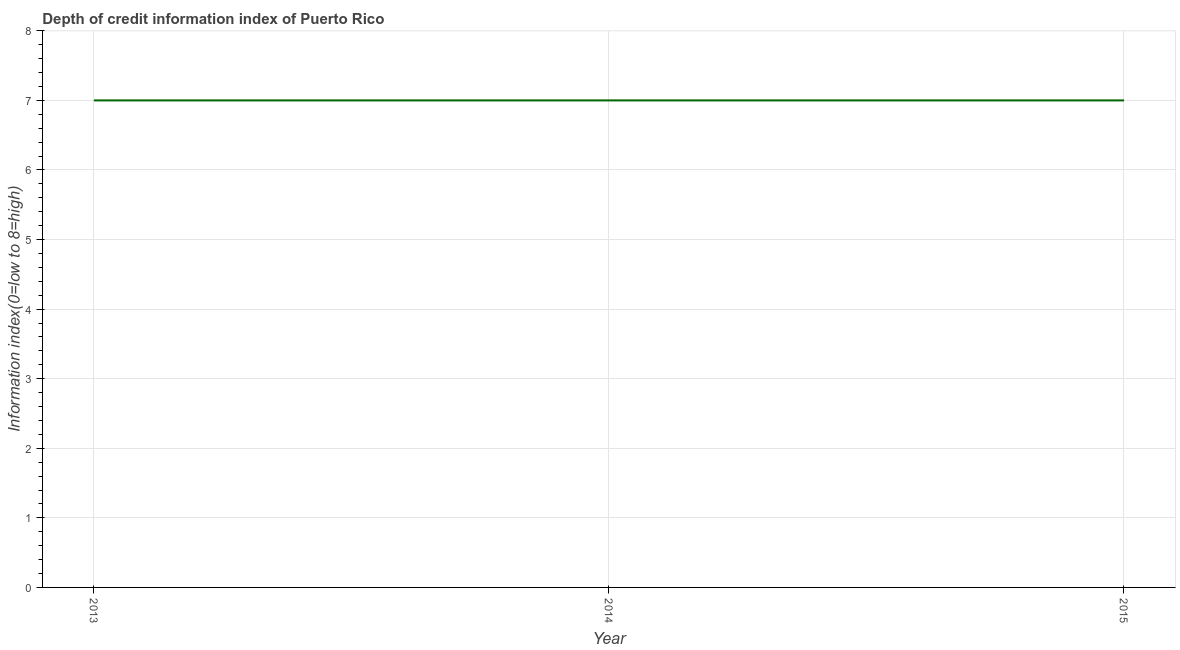What is the depth of credit information index in 2014?
Your answer should be very brief. 7. Across all years, what is the maximum depth of credit information index?
Provide a short and direct response. 7. Across all years, what is the minimum depth of credit information index?
Your response must be concise. 7. In which year was the depth of credit information index maximum?
Provide a succinct answer. 2013. In which year was the depth of credit information index minimum?
Your answer should be very brief. 2013. What is the sum of the depth of credit information index?
Your answer should be very brief. 21. What is the difference between the depth of credit information index in 2014 and 2015?
Provide a succinct answer. 0. What is the average depth of credit information index per year?
Ensure brevity in your answer.  7. In how many years, is the depth of credit information index greater than 3.4 ?
Offer a very short reply. 3. Do a majority of the years between 2015 and 2014 (inclusive) have depth of credit information index greater than 4.2 ?
Ensure brevity in your answer.  No. Is the difference between the depth of credit information index in 2014 and 2015 greater than the difference between any two years?
Make the answer very short. Yes. What is the difference between the highest and the second highest depth of credit information index?
Provide a succinct answer. 0. Is the sum of the depth of credit information index in 2013 and 2015 greater than the maximum depth of credit information index across all years?
Offer a very short reply. Yes. What is the difference between the highest and the lowest depth of credit information index?
Provide a succinct answer. 0. In how many years, is the depth of credit information index greater than the average depth of credit information index taken over all years?
Give a very brief answer. 0. What is the difference between two consecutive major ticks on the Y-axis?
Provide a short and direct response. 1. Are the values on the major ticks of Y-axis written in scientific E-notation?
Offer a terse response. No. Does the graph contain any zero values?
Offer a terse response. No. What is the title of the graph?
Offer a very short reply. Depth of credit information index of Puerto Rico. What is the label or title of the Y-axis?
Keep it short and to the point. Information index(0=low to 8=high). What is the Information index(0=low to 8=high) of 2015?
Provide a succinct answer. 7. What is the difference between the Information index(0=low to 8=high) in 2014 and 2015?
Make the answer very short. 0. What is the ratio of the Information index(0=low to 8=high) in 2013 to that in 2014?
Offer a very short reply. 1. 